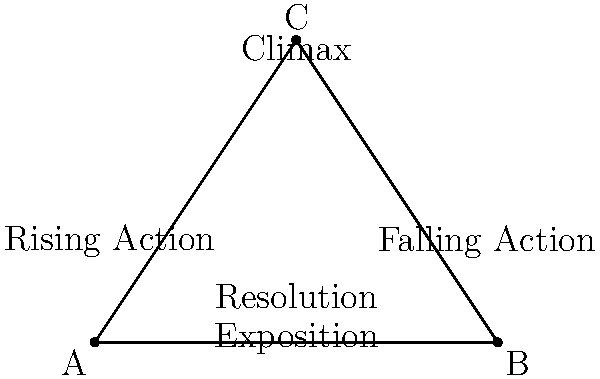In the pyramid diagram representing the classic five-act structure of a screenplay, which element is typically placed at the apex (point C) of the triangle? To answer this question, let's break down the elements of the classic five-act structure as represented in the pyramid diagram:

1. The diagram shows a triangle with five labeled sections, representing the five acts of a classic screenplay structure.

2. The elements are arranged in a specific order, reflecting the progression of the narrative:
   a) At the base of the triangle: Exposition and Resolution
   b) In the middle sections: Rising Action and Falling Action
   c) At the apex (point C): Climax

3. This arrangement visually represents the narrative arc:
   - The story starts with Exposition, introducing characters and setting.
   - It then moves through Rising Action, building tension and conflict.
   - The Climax is placed at the highest point, representing the peak of dramatic tension.
   - Falling Action follows, showing the consequences of the climax.
   - The narrative concludes with Resolution at the base.

4. The question specifically asks about the element at the apex (point C) of the triangle.

5. Looking at the diagram, we can clearly see that "Climax" is positioned at this highest point.

This placement is logical in terms of dramatic structure, as the climax represents the turning point of highest tension in a narrative, from which the action then descends towards resolution.
Answer: Climax 